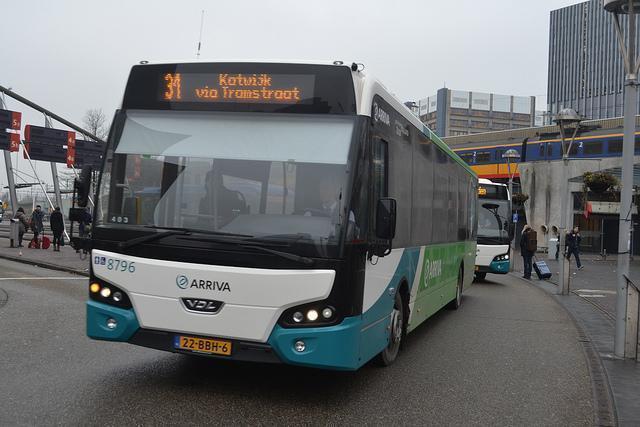Which animal would weigh more than this vehicle if it had no passengers?
From the following set of four choices, select the accurate answer to respond to the question.
Options: Giraffe, elephant, bison, diplodocus. Diplodocus. 